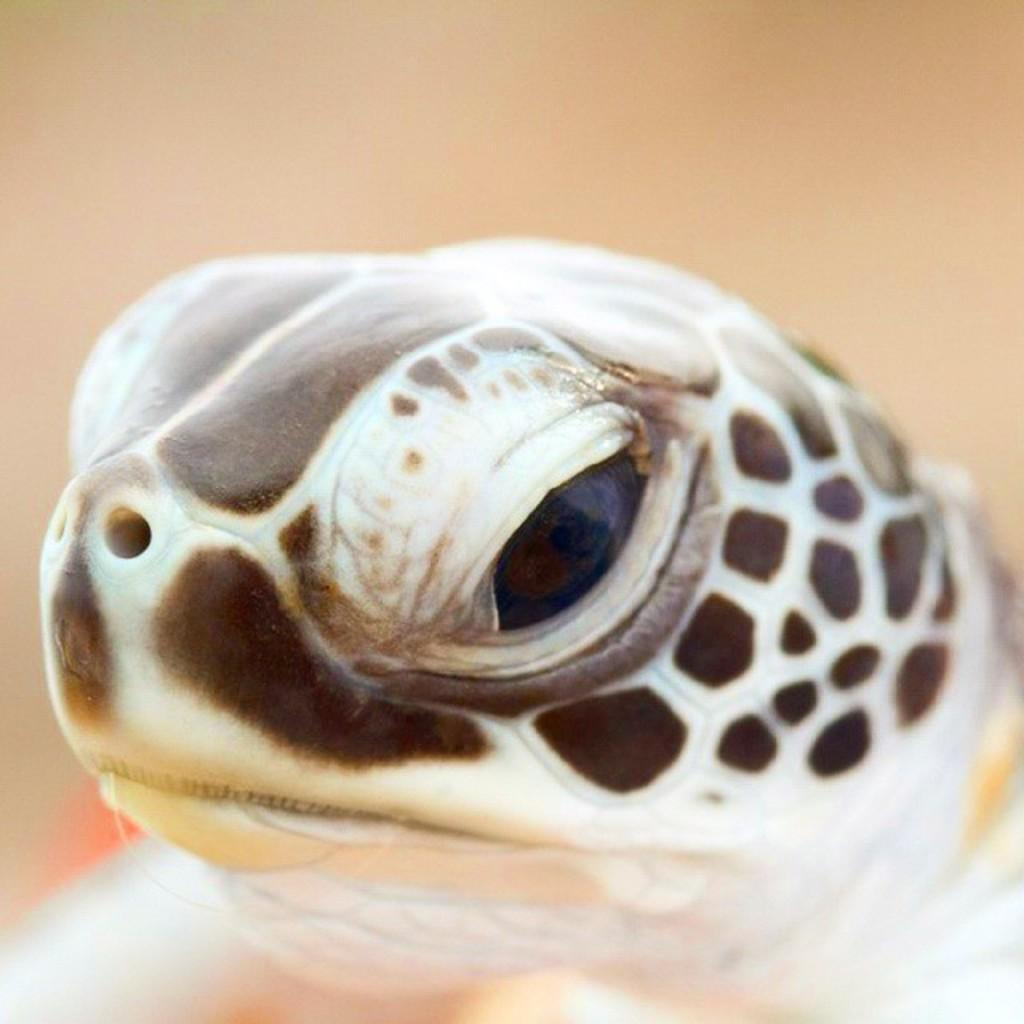What animal is present in the image? There is a turtle in the picture. Can you describe the turtle's appearance? The turtle's head is visible, and it is in brown and white color. What can be said about the background of the image? The background of the image is blurred. What type of harmony is being played by the turtle in the image? There is no indication of music or harmony in the image; it features a turtle with a visible head and brown and white coloring. 